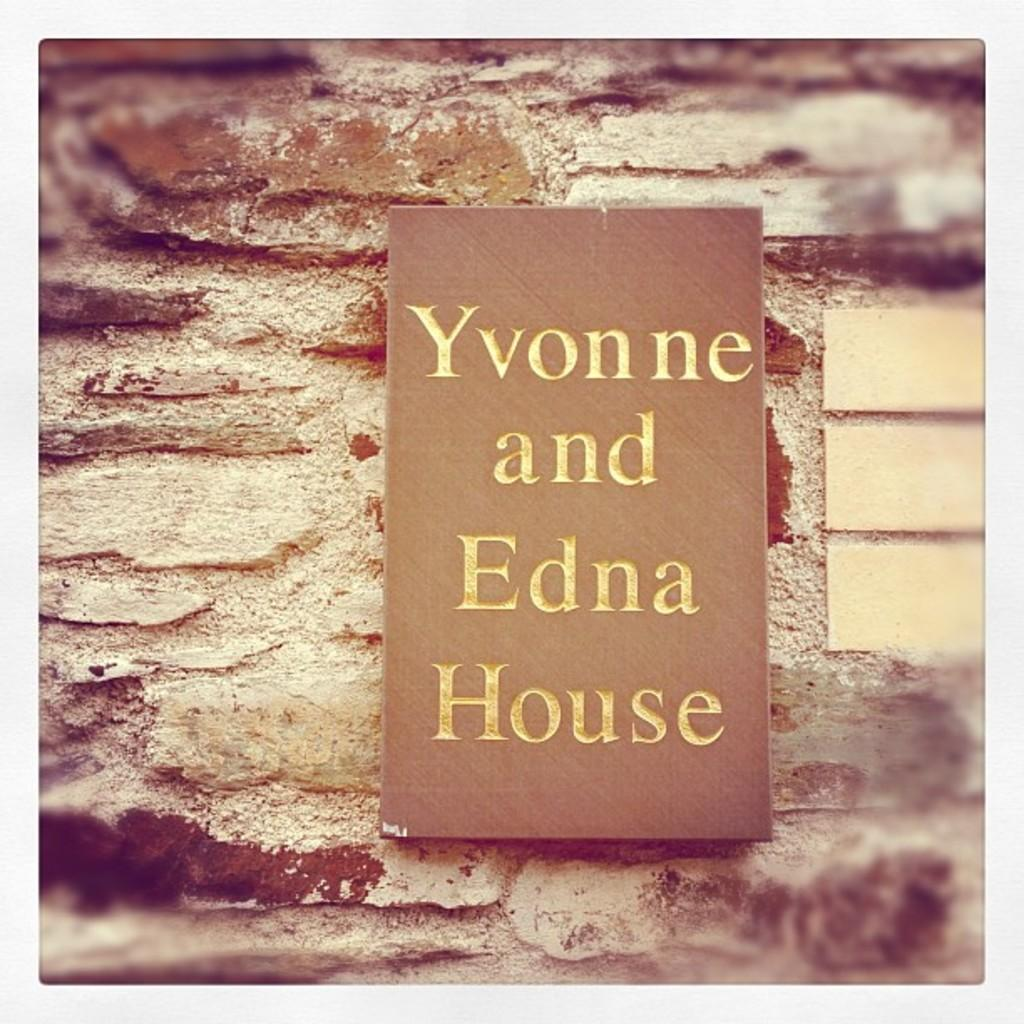Provide a one-sentence caption for the provided image. A sign outside a house called Yvonne and Edna house. 